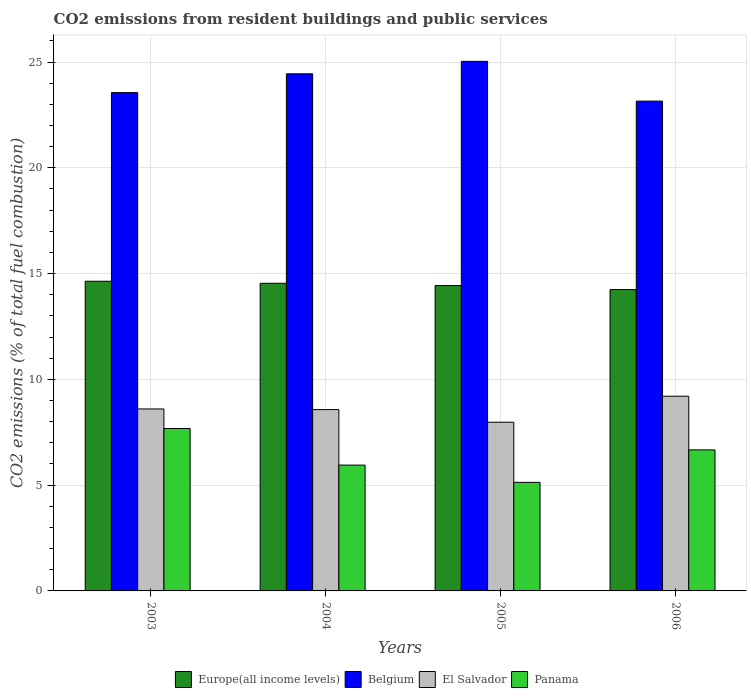How many different coloured bars are there?
Give a very brief answer. 4. How many groups of bars are there?
Offer a very short reply. 4. Are the number of bars per tick equal to the number of legend labels?
Offer a very short reply. Yes. How many bars are there on the 1st tick from the left?
Your answer should be compact. 4. What is the label of the 1st group of bars from the left?
Provide a short and direct response. 2003. What is the total CO2 emitted in El Salvador in 2005?
Offer a terse response. 7.97. Across all years, what is the maximum total CO2 emitted in Belgium?
Your response must be concise. 25.03. Across all years, what is the minimum total CO2 emitted in Belgium?
Give a very brief answer. 23.15. In which year was the total CO2 emitted in El Salvador maximum?
Offer a very short reply. 2006. What is the total total CO2 emitted in El Salvador in the graph?
Make the answer very short. 34.35. What is the difference between the total CO2 emitted in Panama in 2004 and that in 2006?
Your response must be concise. -0.72. What is the difference between the total CO2 emitted in Belgium in 2005 and the total CO2 emitted in Panama in 2006?
Ensure brevity in your answer.  18.36. What is the average total CO2 emitted in Panama per year?
Ensure brevity in your answer.  6.36. In the year 2004, what is the difference between the total CO2 emitted in Panama and total CO2 emitted in Europe(all income levels)?
Ensure brevity in your answer.  -8.59. In how many years, is the total CO2 emitted in El Salvador greater than 17?
Provide a short and direct response. 0. What is the ratio of the total CO2 emitted in El Salvador in 2005 to that in 2006?
Offer a very short reply. 0.87. Is the total CO2 emitted in El Salvador in 2004 less than that in 2005?
Your answer should be very brief. No. What is the difference between the highest and the second highest total CO2 emitted in El Salvador?
Your answer should be compact. 0.6. What is the difference between the highest and the lowest total CO2 emitted in Panama?
Provide a short and direct response. 2.55. In how many years, is the total CO2 emitted in El Salvador greater than the average total CO2 emitted in El Salvador taken over all years?
Keep it short and to the point. 2. Is the sum of the total CO2 emitted in Belgium in 2003 and 2005 greater than the maximum total CO2 emitted in El Salvador across all years?
Your response must be concise. Yes. What does the 3rd bar from the left in 2006 represents?
Keep it short and to the point. El Salvador. Is it the case that in every year, the sum of the total CO2 emitted in Europe(all income levels) and total CO2 emitted in El Salvador is greater than the total CO2 emitted in Panama?
Make the answer very short. Yes. How many bars are there?
Your answer should be compact. 16. Are all the bars in the graph horizontal?
Provide a short and direct response. No. Does the graph contain grids?
Your answer should be compact. Yes. How are the legend labels stacked?
Your answer should be compact. Horizontal. What is the title of the graph?
Offer a very short reply. CO2 emissions from resident buildings and public services. What is the label or title of the X-axis?
Provide a succinct answer. Years. What is the label or title of the Y-axis?
Your answer should be compact. CO2 emissions (% of total fuel combustion). What is the CO2 emissions (% of total fuel combustion) in Europe(all income levels) in 2003?
Your response must be concise. 14.64. What is the CO2 emissions (% of total fuel combustion) in Belgium in 2003?
Your answer should be very brief. 23.55. What is the CO2 emissions (% of total fuel combustion) in El Salvador in 2003?
Offer a terse response. 8.6. What is the CO2 emissions (% of total fuel combustion) of Panama in 2003?
Your answer should be very brief. 7.68. What is the CO2 emissions (% of total fuel combustion) of Europe(all income levels) in 2004?
Provide a succinct answer. 14.54. What is the CO2 emissions (% of total fuel combustion) of Belgium in 2004?
Your answer should be very brief. 24.44. What is the CO2 emissions (% of total fuel combustion) in El Salvador in 2004?
Ensure brevity in your answer.  8.57. What is the CO2 emissions (% of total fuel combustion) in Panama in 2004?
Your answer should be compact. 5.95. What is the CO2 emissions (% of total fuel combustion) of Europe(all income levels) in 2005?
Ensure brevity in your answer.  14.43. What is the CO2 emissions (% of total fuel combustion) in Belgium in 2005?
Keep it short and to the point. 25.03. What is the CO2 emissions (% of total fuel combustion) of El Salvador in 2005?
Offer a terse response. 7.97. What is the CO2 emissions (% of total fuel combustion) of Panama in 2005?
Provide a succinct answer. 5.13. What is the CO2 emissions (% of total fuel combustion) of Europe(all income levels) in 2006?
Your answer should be very brief. 14.25. What is the CO2 emissions (% of total fuel combustion) in Belgium in 2006?
Your answer should be compact. 23.15. What is the CO2 emissions (% of total fuel combustion) of El Salvador in 2006?
Provide a succinct answer. 9.2. What is the CO2 emissions (% of total fuel combustion) of Panama in 2006?
Keep it short and to the point. 6.67. Across all years, what is the maximum CO2 emissions (% of total fuel combustion) in Europe(all income levels)?
Ensure brevity in your answer.  14.64. Across all years, what is the maximum CO2 emissions (% of total fuel combustion) in Belgium?
Offer a very short reply. 25.03. Across all years, what is the maximum CO2 emissions (% of total fuel combustion) in El Salvador?
Provide a succinct answer. 9.2. Across all years, what is the maximum CO2 emissions (% of total fuel combustion) of Panama?
Provide a short and direct response. 7.68. Across all years, what is the minimum CO2 emissions (% of total fuel combustion) of Europe(all income levels)?
Provide a short and direct response. 14.25. Across all years, what is the minimum CO2 emissions (% of total fuel combustion) in Belgium?
Give a very brief answer. 23.15. Across all years, what is the minimum CO2 emissions (% of total fuel combustion) of El Salvador?
Make the answer very short. 7.97. Across all years, what is the minimum CO2 emissions (% of total fuel combustion) of Panama?
Give a very brief answer. 5.13. What is the total CO2 emissions (% of total fuel combustion) in Europe(all income levels) in the graph?
Your answer should be very brief. 57.86. What is the total CO2 emissions (% of total fuel combustion) in Belgium in the graph?
Provide a short and direct response. 96.18. What is the total CO2 emissions (% of total fuel combustion) of El Salvador in the graph?
Your answer should be compact. 34.35. What is the total CO2 emissions (% of total fuel combustion) in Panama in the graph?
Keep it short and to the point. 25.42. What is the difference between the CO2 emissions (% of total fuel combustion) of Europe(all income levels) in 2003 and that in 2004?
Offer a very short reply. 0.1. What is the difference between the CO2 emissions (% of total fuel combustion) of Belgium in 2003 and that in 2004?
Provide a short and direct response. -0.89. What is the difference between the CO2 emissions (% of total fuel combustion) in El Salvador in 2003 and that in 2004?
Offer a terse response. 0.03. What is the difference between the CO2 emissions (% of total fuel combustion) of Panama in 2003 and that in 2004?
Ensure brevity in your answer.  1.73. What is the difference between the CO2 emissions (% of total fuel combustion) in Europe(all income levels) in 2003 and that in 2005?
Provide a succinct answer. 0.2. What is the difference between the CO2 emissions (% of total fuel combustion) in Belgium in 2003 and that in 2005?
Keep it short and to the point. -1.48. What is the difference between the CO2 emissions (% of total fuel combustion) of El Salvador in 2003 and that in 2005?
Provide a succinct answer. 0.63. What is the difference between the CO2 emissions (% of total fuel combustion) in Panama in 2003 and that in 2005?
Make the answer very short. 2.55. What is the difference between the CO2 emissions (% of total fuel combustion) of Europe(all income levels) in 2003 and that in 2006?
Keep it short and to the point. 0.39. What is the difference between the CO2 emissions (% of total fuel combustion) in Belgium in 2003 and that in 2006?
Your answer should be very brief. 0.4. What is the difference between the CO2 emissions (% of total fuel combustion) of El Salvador in 2003 and that in 2006?
Provide a short and direct response. -0.6. What is the difference between the CO2 emissions (% of total fuel combustion) in Panama in 2003 and that in 2006?
Offer a very short reply. 1.01. What is the difference between the CO2 emissions (% of total fuel combustion) of Europe(all income levels) in 2004 and that in 2005?
Make the answer very short. 0.11. What is the difference between the CO2 emissions (% of total fuel combustion) of Belgium in 2004 and that in 2005?
Your answer should be very brief. -0.59. What is the difference between the CO2 emissions (% of total fuel combustion) in El Salvador in 2004 and that in 2005?
Provide a succinct answer. 0.6. What is the difference between the CO2 emissions (% of total fuel combustion) in Panama in 2004 and that in 2005?
Offer a terse response. 0.82. What is the difference between the CO2 emissions (% of total fuel combustion) in Europe(all income levels) in 2004 and that in 2006?
Your answer should be very brief. 0.3. What is the difference between the CO2 emissions (% of total fuel combustion) in Belgium in 2004 and that in 2006?
Offer a terse response. 1.29. What is the difference between the CO2 emissions (% of total fuel combustion) of El Salvador in 2004 and that in 2006?
Offer a terse response. -0.63. What is the difference between the CO2 emissions (% of total fuel combustion) of Panama in 2004 and that in 2006?
Your answer should be compact. -0.72. What is the difference between the CO2 emissions (% of total fuel combustion) of Europe(all income levels) in 2005 and that in 2006?
Your answer should be very brief. 0.19. What is the difference between the CO2 emissions (% of total fuel combustion) of Belgium in 2005 and that in 2006?
Your response must be concise. 1.88. What is the difference between the CO2 emissions (% of total fuel combustion) of El Salvador in 2005 and that in 2006?
Your response must be concise. -1.23. What is the difference between the CO2 emissions (% of total fuel combustion) of Panama in 2005 and that in 2006?
Give a very brief answer. -1.53. What is the difference between the CO2 emissions (% of total fuel combustion) in Europe(all income levels) in 2003 and the CO2 emissions (% of total fuel combustion) in Belgium in 2004?
Give a very brief answer. -9.8. What is the difference between the CO2 emissions (% of total fuel combustion) of Europe(all income levels) in 2003 and the CO2 emissions (% of total fuel combustion) of El Salvador in 2004?
Provide a short and direct response. 6.07. What is the difference between the CO2 emissions (% of total fuel combustion) of Europe(all income levels) in 2003 and the CO2 emissions (% of total fuel combustion) of Panama in 2004?
Your answer should be very brief. 8.69. What is the difference between the CO2 emissions (% of total fuel combustion) of Belgium in 2003 and the CO2 emissions (% of total fuel combustion) of El Salvador in 2004?
Offer a terse response. 14.98. What is the difference between the CO2 emissions (% of total fuel combustion) in Belgium in 2003 and the CO2 emissions (% of total fuel combustion) in Panama in 2004?
Make the answer very short. 17.6. What is the difference between the CO2 emissions (% of total fuel combustion) in El Salvador in 2003 and the CO2 emissions (% of total fuel combustion) in Panama in 2004?
Your answer should be very brief. 2.65. What is the difference between the CO2 emissions (% of total fuel combustion) of Europe(all income levels) in 2003 and the CO2 emissions (% of total fuel combustion) of Belgium in 2005?
Offer a terse response. -10.39. What is the difference between the CO2 emissions (% of total fuel combustion) of Europe(all income levels) in 2003 and the CO2 emissions (% of total fuel combustion) of El Salvador in 2005?
Offer a very short reply. 6.66. What is the difference between the CO2 emissions (% of total fuel combustion) in Europe(all income levels) in 2003 and the CO2 emissions (% of total fuel combustion) in Panama in 2005?
Provide a short and direct response. 9.51. What is the difference between the CO2 emissions (% of total fuel combustion) of Belgium in 2003 and the CO2 emissions (% of total fuel combustion) of El Salvador in 2005?
Offer a very short reply. 15.58. What is the difference between the CO2 emissions (% of total fuel combustion) of Belgium in 2003 and the CO2 emissions (% of total fuel combustion) of Panama in 2005?
Give a very brief answer. 18.42. What is the difference between the CO2 emissions (% of total fuel combustion) in El Salvador in 2003 and the CO2 emissions (% of total fuel combustion) in Panama in 2005?
Your answer should be very brief. 3.47. What is the difference between the CO2 emissions (% of total fuel combustion) in Europe(all income levels) in 2003 and the CO2 emissions (% of total fuel combustion) in Belgium in 2006?
Provide a succinct answer. -8.51. What is the difference between the CO2 emissions (% of total fuel combustion) in Europe(all income levels) in 2003 and the CO2 emissions (% of total fuel combustion) in El Salvador in 2006?
Your answer should be very brief. 5.44. What is the difference between the CO2 emissions (% of total fuel combustion) of Europe(all income levels) in 2003 and the CO2 emissions (% of total fuel combustion) of Panama in 2006?
Make the answer very short. 7.97. What is the difference between the CO2 emissions (% of total fuel combustion) in Belgium in 2003 and the CO2 emissions (% of total fuel combustion) in El Salvador in 2006?
Make the answer very short. 14.35. What is the difference between the CO2 emissions (% of total fuel combustion) in Belgium in 2003 and the CO2 emissions (% of total fuel combustion) in Panama in 2006?
Your answer should be very brief. 16.89. What is the difference between the CO2 emissions (% of total fuel combustion) of El Salvador in 2003 and the CO2 emissions (% of total fuel combustion) of Panama in 2006?
Your answer should be compact. 1.93. What is the difference between the CO2 emissions (% of total fuel combustion) in Europe(all income levels) in 2004 and the CO2 emissions (% of total fuel combustion) in Belgium in 2005?
Keep it short and to the point. -10.49. What is the difference between the CO2 emissions (% of total fuel combustion) in Europe(all income levels) in 2004 and the CO2 emissions (% of total fuel combustion) in El Salvador in 2005?
Ensure brevity in your answer.  6.57. What is the difference between the CO2 emissions (% of total fuel combustion) of Europe(all income levels) in 2004 and the CO2 emissions (% of total fuel combustion) of Panama in 2005?
Provide a succinct answer. 9.41. What is the difference between the CO2 emissions (% of total fuel combustion) of Belgium in 2004 and the CO2 emissions (% of total fuel combustion) of El Salvador in 2005?
Offer a terse response. 16.47. What is the difference between the CO2 emissions (% of total fuel combustion) in Belgium in 2004 and the CO2 emissions (% of total fuel combustion) in Panama in 2005?
Offer a very short reply. 19.31. What is the difference between the CO2 emissions (% of total fuel combustion) in El Salvador in 2004 and the CO2 emissions (% of total fuel combustion) in Panama in 2005?
Make the answer very short. 3.44. What is the difference between the CO2 emissions (% of total fuel combustion) in Europe(all income levels) in 2004 and the CO2 emissions (% of total fuel combustion) in Belgium in 2006?
Keep it short and to the point. -8.61. What is the difference between the CO2 emissions (% of total fuel combustion) of Europe(all income levels) in 2004 and the CO2 emissions (% of total fuel combustion) of El Salvador in 2006?
Keep it short and to the point. 5.34. What is the difference between the CO2 emissions (% of total fuel combustion) of Europe(all income levels) in 2004 and the CO2 emissions (% of total fuel combustion) of Panama in 2006?
Offer a terse response. 7.87. What is the difference between the CO2 emissions (% of total fuel combustion) in Belgium in 2004 and the CO2 emissions (% of total fuel combustion) in El Salvador in 2006?
Keep it short and to the point. 15.24. What is the difference between the CO2 emissions (% of total fuel combustion) in Belgium in 2004 and the CO2 emissions (% of total fuel combustion) in Panama in 2006?
Provide a succinct answer. 17.78. What is the difference between the CO2 emissions (% of total fuel combustion) of El Salvador in 2004 and the CO2 emissions (% of total fuel combustion) of Panama in 2006?
Offer a very short reply. 1.9. What is the difference between the CO2 emissions (% of total fuel combustion) in Europe(all income levels) in 2005 and the CO2 emissions (% of total fuel combustion) in Belgium in 2006?
Your response must be concise. -8.72. What is the difference between the CO2 emissions (% of total fuel combustion) in Europe(all income levels) in 2005 and the CO2 emissions (% of total fuel combustion) in El Salvador in 2006?
Your answer should be compact. 5.23. What is the difference between the CO2 emissions (% of total fuel combustion) of Europe(all income levels) in 2005 and the CO2 emissions (% of total fuel combustion) of Panama in 2006?
Give a very brief answer. 7.77. What is the difference between the CO2 emissions (% of total fuel combustion) in Belgium in 2005 and the CO2 emissions (% of total fuel combustion) in El Salvador in 2006?
Your answer should be very brief. 15.83. What is the difference between the CO2 emissions (% of total fuel combustion) of Belgium in 2005 and the CO2 emissions (% of total fuel combustion) of Panama in 2006?
Offer a terse response. 18.36. What is the difference between the CO2 emissions (% of total fuel combustion) of El Salvador in 2005 and the CO2 emissions (% of total fuel combustion) of Panama in 2006?
Give a very brief answer. 1.31. What is the average CO2 emissions (% of total fuel combustion) in Europe(all income levels) per year?
Give a very brief answer. 14.46. What is the average CO2 emissions (% of total fuel combustion) of Belgium per year?
Ensure brevity in your answer.  24.04. What is the average CO2 emissions (% of total fuel combustion) in El Salvador per year?
Keep it short and to the point. 8.59. What is the average CO2 emissions (% of total fuel combustion) in Panama per year?
Your response must be concise. 6.36. In the year 2003, what is the difference between the CO2 emissions (% of total fuel combustion) of Europe(all income levels) and CO2 emissions (% of total fuel combustion) of Belgium?
Ensure brevity in your answer.  -8.91. In the year 2003, what is the difference between the CO2 emissions (% of total fuel combustion) in Europe(all income levels) and CO2 emissions (% of total fuel combustion) in El Salvador?
Your response must be concise. 6.04. In the year 2003, what is the difference between the CO2 emissions (% of total fuel combustion) of Europe(all income levels) and CO2 emissions (% of total fuel combustion) of Panama?
Keep it short and to the point. 6.96. In the year 2003, what is the difference between the CO2 emissions (% of total fuel combustion) of Belgium and CO2 emissions (% of total fuel combustion) of El Salvador?
Make the answer very short. 14.95. In the year 2003, what is the difference between the CO2 emissions (% of total fuel combustion) of Belgium and CO2 emissions (% of total fuel combustion) of Panama?
Your response must be concise. 15.87. In the year 2003, what is the difference between the CO2 emissions (% of total fuel combustion) in El Salvador and CO2 emissions (% of total fuel combustion) in Panama?
Your response must be concise. 0.92. In the year 2004, what is the difference between the CO2 emissions (% of total fuel combustion) of Europe(all income levels) and CO2 emissions (% of total fuel combustion) of Belgium?
Provide a short and direct response. -9.9. In the year 2004, what is the difference between the CO2 emissions (% of total fuel combustion) of Europe(all income levels) and CO2 emissions (% of total fuel combustion) of El Salvador?
Your response must be concise. 5.97. In the year 2004, what is the difference between the CO2 emissions (% of total fuel combustion) of Europe(all income levels) and CO2 emissions (% of total fuel combustion) of Panama?
Offer a very short reply. 8.59. In the year 2004, what is the difference between the CO2 emissions (% of total fuel combustion) in Belgium and CO2 emissions (% of total fuel combustion) in El Salvador?
Your response must be concise. 15.87. In the year 2004, what is the difference between the CO2 emissions (% of total fuel combustion) in Belgium and CO2 emissions (% of total fuel combustion) in Panama?
Ensure brevity in your answer.  18.49. In the year 2004, what is the difference between the CO2 emissions (% of total fuel combustion) in El Salvador and CO2 emissions (% of total fuel combustion) in Panama?
Give a very brief answer. 2.62. In the year 2005, what is the difference between the CO2 emissions (% of total fuel combustion) of Europe(all income levels) and CO2 emissions (% of total fuel combustion) of Belgium?
Make the answer very short. -10.6. In the year 2005, what is the difference between the CO2 emissions (% of total fuel combustion) in Europe(all income levels) and CO2 emissions (% of total fuel combustion) in El Salvador?
Make the answer very short. 6.46. In the year 2005, what is the difference between the CO2 emissions (% of total fuel combustion) in Europe(all income levels) and CO2 emissions (% of total fuel combustion) in Panama?
Your response must be concise. 9.3. In the year 2005, what is the difference between the CO2 emissions (% of total fuel combustion) of Belgium and CO2 emissions (% of total fuel combustion) of El Salvador?
Your response must be concise. 17.06. In the year 2005, what is the difference between the CO2 emissions (% of total fuel combustion) of Belgium and CO2 emissions (% of total fuel combustion) of Panama?
Keep it short and to the point. 19.9. In the year 2005, what is the difference between the CO2 emissions (% of total fuel combustion) of El Salvador and CO2 emissions (% of total fuel combustion) of Panama?
Provide a succinct answer. 2.84. In the year 2006, what is the difference between the CO2 emissions (% of total fuel combustion) in Europe(all income levels) and CO2 emissions (% of total fuel combustion) in Belgium?
Ensure brevity in your answer.  -8.91. In the year 2006, what is the difference between the CO2 emissions (% of total fuel combustion) in Europe(all income levels) and CO2 emissions (% of total fuel combustion) in El Salvador?
Offer a terse response. 5.04. In the year 2006, what is the difference between the CO2 emissions (% of total fuel combustion) of Europe(all income levels) and CO2 emissions (% of total fuel combustion) of Panama?
Provide a short and direct response. 7.58. In the year 2006, what is the difference between the CO2 emissions (% of total fuel combustion) in Belgium and CO2 emissions (% of total fuel combustion) in El Salvador?
Ensure brevity in your answer.  13.95. In the year 2006, what is the difference between the CO2 emissions (% of total fuel combustion) in Belgium and CO2 emissions (% of total fuel combustion) in Panama?
Offer a very short reply. 16.48. In the year 2006, what is the difference between the CO2 emissions (% of total fuel combustion) in El Salvador and CO2 emissions (% of total fuel combustion) in Panama?
Your answer should be very brief. 2.54. What is the ratio of the CO2 emissions (% of total fuel combustion) in Belgium in 2003 to that in 2004?
Offer a very short reply. 0.96. What is the ratio of the CO2 emissions (% of total fuel combustion) in Panama in 2003 to that in 2004?
Provide a short and direct response. 1.29. What is the ratio of the CO2 emissions (% of total fuel combustion) in Europe(all income levels) in 2003 to that in 2005?
Offer a very short reply. 1.01. What is the ratio of the CO2 emissions (% of total fuel combustion) in Belgium in 2003 to that in 2005?
Your answer should be very brief. 0.94. What is the ratio of the CO2 emissions (% of total fuel combustion) of El Salvador in 2003 to that in 2005?
Give a very brief answer. 1.08. What is the ratio of the CO2 emissions (% of total fuel combustion) in Panama in 2003 to that in 2005?
Offer a very short reply. 1.5. What is the ratio of the CO2 emissions (% of total fuel combustion) in Europe(all income levels) in 2003 to that in 2006?
Make the answer very short. 1.03. What is the ratio of the CO2 emissions (% of total fuel combustion) in Belgium in 2003 to that in 2006?
Your response must be concise. 1.02. What is the ratio of the CO2 emissions (% of total fuel combustion) in El Salvador in 2003 to that in 2006?
Make the answer very short. 0.93. What is the ratio of the CO2 emissions (% of total fuel combustion) in Panama in 2003 to that in 2006?
Offer a terse response. 1.15. What is the ratio of the CO2 emissions (% of total fuel combustion) in Europe(all income levels) in 2004 to that in 2005?
Provide a succinct answer. 1.01. What is the ratio of the CO2 emissions (% of total fuel combustion) of Belgium in 2004 to that in 2005?
Provide a short and direct response. 0.98. What is the ratio of the CO2 emissions (% of total fuel combustion) in El Salvador in 2004 to that in 2005?
Provide a succinct answer. 1.07. What is the ratio of the CO2 emissions (% of total fuel combustion) of Panama in 2004 to that in 2005?
Keep it short and to the point. 1.16. What is the ratio of the CO2 emissions (% of total fuel combustion) of Europe(all income levels) in 2004 to that in 2006?
Offer a terse response. 1.02. What is the ratio of the CO2 emissions (% of total fuel combustion) of Belgium in 2004 to that in 2006?
Offer a terse response. 1.06. What is the ratio of the CO2 emissions (% of total fuel combustion) of El Salvador in 2004 to that in 2006?
Your answer should be compact. 0.93. What is the ratio of the CO2 emissions (% of total fuel combustion) of Panama in 2004 to that in 2006?
Ensure brevity in your answer.  0.89. What is the ratio of the CO2 emissions (% of total fuel combustion) of Europe(all income levels) in 2005 to that in 2006?
Keep it short and to the point. 1.01. What is the ratio of the CO2 emissions (% of total fuel combustion) of Belgium in 2005 to that in 2006?
Make the answer very short. 1.08. What is the ratio of the CO2 emissions (% of total fuel combustion) in El Salvador in 2005 to that in 2006?
Provide a succinct answer. 0.87. What is the ratio of the CO2 emissions (% of total fuel combustion) in Panama in 2005 to that in 2006?
Keep it short and to the point. 0.77. What is the difference between the highest and the second highest CO2 emissions (% of total fuel combustion) of Europe(all income levels)?
Ensure brevity in your answer.  0.1. What is the difference between the highest and the second highest CO2 emissions (% of total fuel combustion) in Belgium?
Make the answer very short. 0.59. What is the difference between the highest and the second highest CO2 emissions (% of total fuel combustion) in El Salvador?
Provide a succinct answer. 0.6. What is the difference between the highest and the second highest CO2 emissions (% of total fuel combustion) of Panama?
Keep it short and to the point. 1.01. What is the difference between the highest and the lowest CO2 emissions (% of total fuel combustion) of Europe(all income levels)?
Keep it short and to the point. 0.39. What is the difference between the highest and the lowest CO2 emissions (% of total fuel combustion) in Belgium?
Offer a terse response. 1.88. What is the difference between the highest and the lowest CO2 emissions (% of total fuel combustion) of El Salvador?
Your answer should be compact. 1.23. What is the difference between the highest and the lowest CO2 emissions (% of total fuel combustion) in Panama?
Provide a succinct answer. 2.55. 